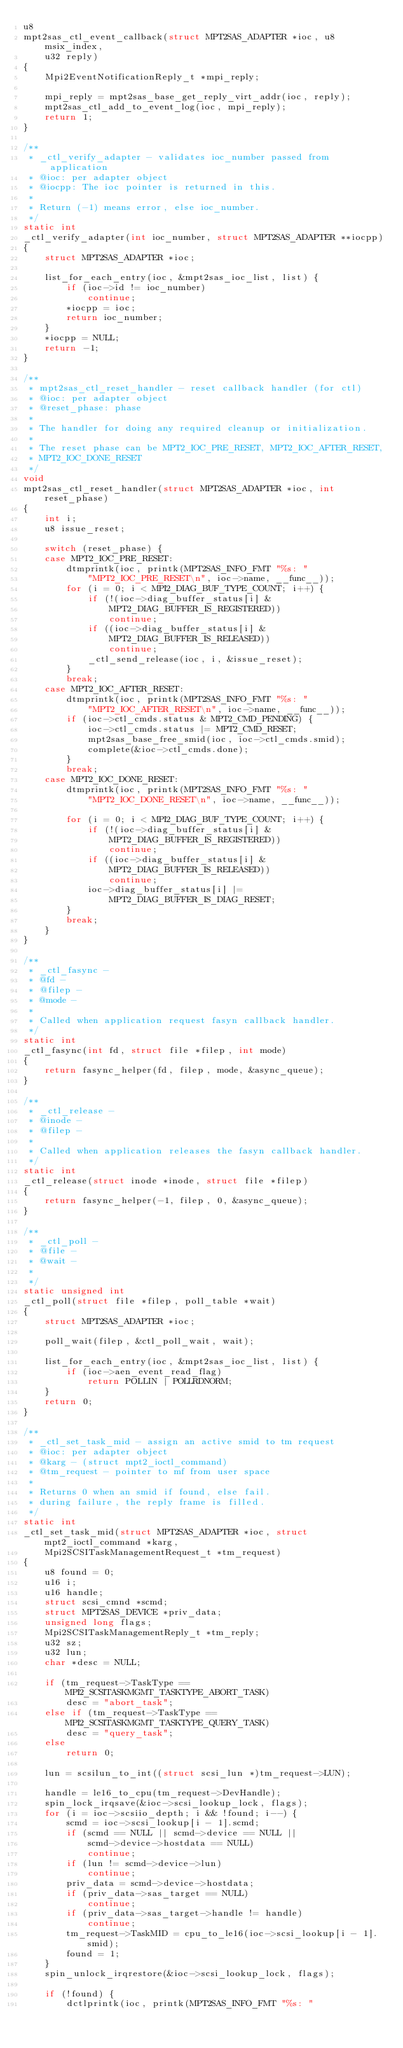Convert code to text. <code><loc_0><loc_0><loc_500><loc_500><_C_>u8
mpt2sas_ctl_event_callback(struct MPT2SAS_ADAPTER *ioc, u8 msix_index,
	u32 reply)
{
	Mpi2EventNotificationReply_t *mpi_reply;

	mpi_reply = mpt2sas_base_get_reply_virt_addr(ioc, reply);
	mpt2sas_ctl_add_to_event_log(ioc, mpi_reply);
	return 1;
}

/**
 * _ctl_verify_adapter - validates ioc_number passed from application
 * @ioc: per adapter object
 * @iocpp: The ioc pointer is returned in this.
 *
 * Return (-1) means error, else ioc_number.
 */
static int
_ctl_verify_adapter(int ioc_number, struct MPT2SAS_ADAPTER **iocpp)
{
	struct MPT2SAS_ADAPTER *ioc;

	list_for_each_entry(ioc, &mpt2sas_ioc_list, list) {
		if (ioc->id != ioc_number)
			continue;
		*iocpp = ioc;
		return ioc_number;
	}
	*iocpp = NULL;
	return -1;
}

/**
 * mpt2sas_ctl_reset_handler - reset callback handler (for ctl)
 * @ioc: per adapter object
 * @reset_phase: phase
 *
 * The handler for doing any required cleanup or initialization.
 *
 * The reset phase can be MPT2_IOC_PRE_RESET, MPT2_IOC_AFTER_RESET,
 * MPT2_IOC_DONE_RESET
 */
void
mpt2sas_ctl_reset_handler(struct MPT2SAS_ADAPTER *ioc, int reset_phase)
{
	int i;
	u8 issue_reset;

	switch (reset_phase) {
	case MPT2_IOC_PRE_RESET:
		dtmprintk(ioc, printk(MPT2SAS_INFO_FMT "%s: "
		    "MPT2_IOC_PRE_RESET\n", ioc->name, __func__));
		for (i = 0; i < MPI2_DIAG_BUF_TYPE_COUNT; i++) {
			if (!(ioc->diag_buffer_status[i] &
			    MPT2_DIAG_BUFFER_IS_REGISTERED))
				continue;
			if ((ioc->diag_buffer_status[i] &
			    MPT2_DIAG_BUFFER_IS_RELEASED))
				continue;
			_ctl_send_release(ioc, i, &issue_reset);
		}
		break;
	case MPT2_IOC_AFTER_RESET:
		dtmprintk(ioc, printk(MPT2SAS_INFO_FMT "%s: "
		    "MPT2_IOC_AFTER_RESET\n", ioc->name, __func__));
		if (ioc->ctl_cmds.status & MPT2_CMD_PENDING) {
			ioc->ctl_cmds.status |= MPT2_CMD_RESET;
			mpt2sas_base_free_smid(ioc, ioc->ctl_cmds.smid);
			complete(&ioc->ctl_cmds.done);
		}
		break;
	case MPT2_IOC_DONE_RESET:
		dtmprintk(ioc, printk(MPT2SAS_INFO_FMT "%s: "
		    "MPT2_IOC_DONE_RESET\n", ioc->name, __func__));

		for (i = 0; i < MPI2_DIAG_BUF_TYPE_COUNT; i++) {
			if (!(ioc->diag_buffer_status[i] &
			    MPT2_DIAG_BUFFER_IS_REGISTERED))
				continue;
			if ((ioc->diag_buffer_status[i] &
			    MPT2_DIAG_BUFFER_IS_RELEASED))
				continue;
			ioc->diag_buffer_status[i] |=
			    MPT2_DIAG_BUFFER_IS_DIAG_RESET;
		}
		break;
	}
}

/**
 * _ctl_fasync -
 * @fd -
 * @filep -
 * @mode -
 *
 * Called when application request fasyn callback handler.
 */
static int
_ctl_fasync(int fd, struct file *filep, int mode)
{
	return fasync_helper(fd, filep, mode, &async_queue);
}

/**
 * _ctl_release -
 * @inode -
 * @filep -
 *
 * Called when application releases the fasyn callback handler.
 */
static int
_ctl_release(struct inode *inode, struct file *filep)
{
	return fasync_helper(-1, filep, 0, &async_queue);
}

/**
 * _ctl_poll -
 * @file -
 * @wait -
 *
 */
static unsigned int
_ctl_poll(struct file *filep, poll_table *wait)
{
	struct MPT2SAS_ADAPTER *ioc;

	poll_wait(filep, &ctl_poll_wait, wait);

	list_for_each_entry(ioc, &mpt2sas_ioc_list, list) {
		if (ioc->aen_event_read_flag)
			return POLLIN | POLLRDNORM;
	}
	return 0;
}

/**
 * _ctl_set_task_mid - assign an active smid to tm request
 * @ioc: per adapter object
 * @karg - (struct mpt2_ioctl_command)
 * @tm_request - pointer to mf from user space
 *
 * Returns 0 when an smid if found, else fail.
 * during failure, the reply frame is filled.
 */
static int
_ctl_set_task_mid(struct MPT2SAS_ADAPTER *ioc, struct mpt2_ioctl_command *karg,
    Mpi2SCSITaskManagementRequest_t *tm_request)
{
	u8 found = 0;
	u16 i;
	u16 handle;
	struct scsi_cmnd *scmd;
	struct MPT2SAS_DEVICE *priv_data;
	unsigned long flags;
	Mpi2SCSITaskManagementReply_t *tm_reply;
	u32 sz;
	u32 lun;
	char *desc = NULL;

	if (tm_request->TaskType == MPI2_SCSITASKMGMT_TASKTYPE_ABORT_TASK)
		desc = "abort_task";
	else if (tm_request->TaskType == MPI2_SCSITASKMGMT_TASKTYPE_QUERY_TASK)
		desc = "query_task";
	else
		return 0;

	lun = scsilun_to_int((struct scsi_lun *)tm_request->LUN);

	handle = le16_to_cpu(tm_request->DevHandle);
	spin_lock_irqsave(&ioc->scsi_lookup_lock, flags);
	for (i = ioc->scsiio_depth; i && !found; i--) {
		scmd = ioc->scsi_lookup[i - 1].scmd;
		if (scmd == NULL || scmd->device == NULL ||
		    scmd->device->hostdata == NULL)
			continue;
		if (lun != scmd->device->lun)
			continue;
		priv_data = scmd->device->hostdata;
		if (priv_data->sas_target == NULL)
			continue;
		if (priv_data->sas_target->handle != handle)
			continue;
		tm_request->TaskMID = cpu_to_le16(ioc->scsi_lookup[i - 1].smid);
		found = 1;
	}
	spin_unlock_irqrestore(&ioc->scsi_lookup_lock, flags);

	if (!found) {
		dctlprintk(ioc, printk(MPT2SAS_INFO_FMT "%s: "</code> 